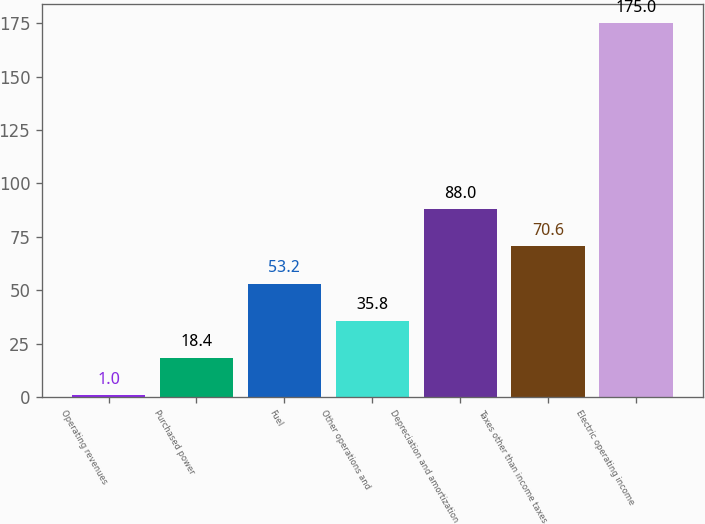Convert chart. <chart><loc_0><loc_0><loc_500><loc_500><bar_chart><fcel>Operating revenues<fcel>Purchased power<fcel>Fuel<fcel>Other operations and<fcel>Depreciation and amortization<fcel>Taxes other than income taxes<fcel>Electric operating income<nl><fcel>1<fcel>18.4<fcel>53.2<fcel>35.8<fcel>88<fcel>70.6<fcel>175<nl></chart> 